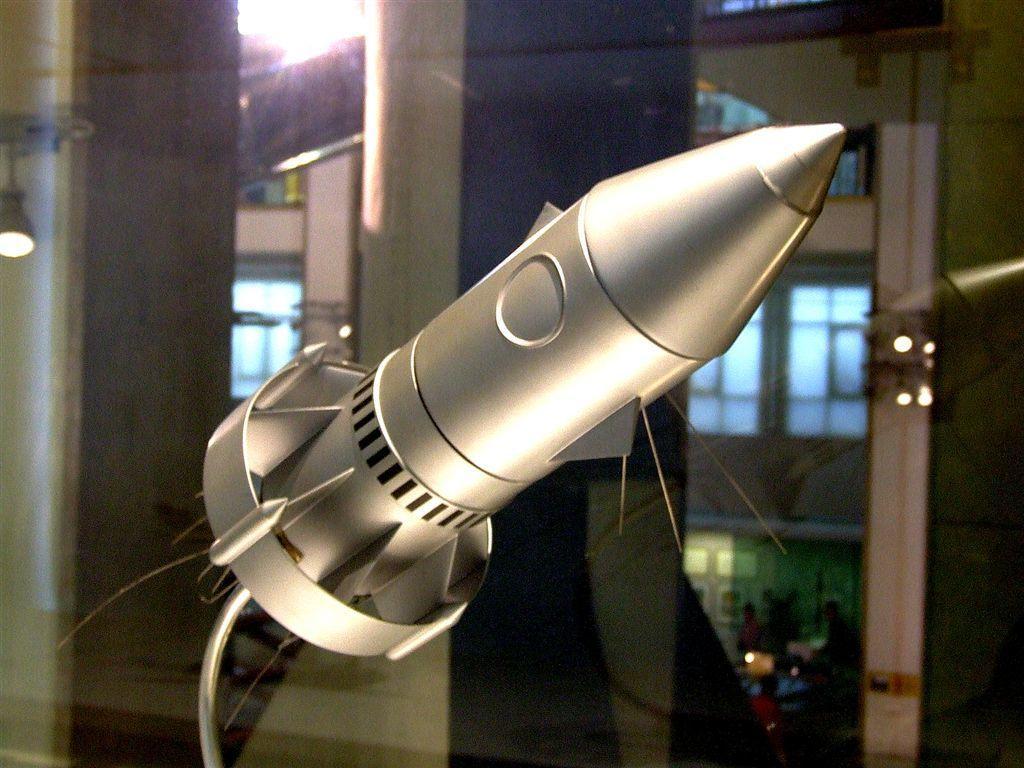Could you give a brief overview of what you see in this image? In this picture I can see there is a metal object and it is placed in a glass container. In the backdrop, there are pillars and lights attached to the ceiling. 